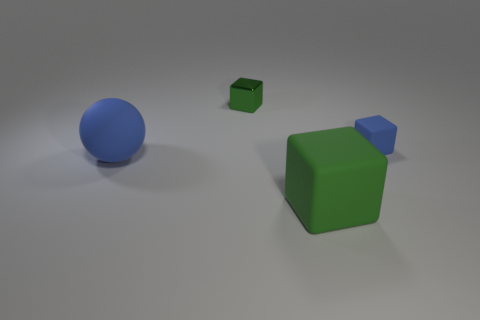Subtract all metal blocks. How many blocks are left? 2 Add 4 large purple metal cylinders. How many objects exist? 8 Subtract all spheres. How many objects are left? 3 Subtract all brown cylinders. How many green blocks are left? 2 Subtract 1 spheres. How many spheres are left? 0 Subtract all blue cubes. How many cubes are left? 2 Subtract all yellow cubes. Subtract all red cylinders. How many cubes are left? 3 Subtract 0 cyan cubes. How many objects are left? 4 Subtract all small blue rubber objects. Subtract all big yellow matte cubes. How many objects are left? 3 Add 1 large blue spheres. How many large blue spheres are left? 2 